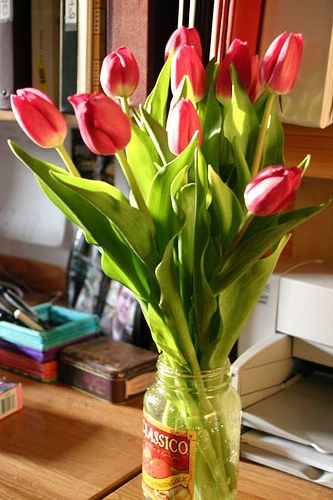Describe the objects in this image and their specific colors. I can see potted plant in lightgray, olive, black, and darkgreen tones, bottle in lightgray, olive, and khaki tones, book in lightgray, black, maroon, and gray tones, book in lightgray, maroon, black, and brown tones, and book in lightgray, black, gray, and darkgray tones in this image. 